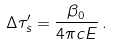<formula> <loc_0><loc_0><loc_500><loc_500>\Delta \tau _ { s } ^ { \prime } = \frac { \beta _ { 0 } } { 4 \pi c E } \, .</formula> 